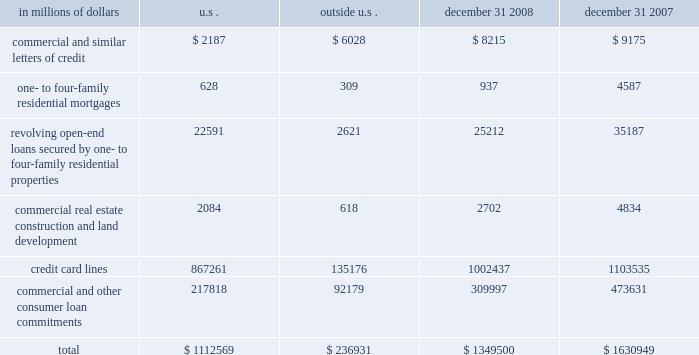Credit commitments the table below summarizes citigroup 2019s other commitments as of december 31 , 2008 and december 31 , 2007 .
In millions of dollars u.s .
Outside december 31 , december 31 .
The majority of unused commitments are contingent upon customers 2019 maintaining specific credit standards .
Commercial commitments generally have floating interest rates and fixed expiration dates and may require payment of fees .
Such fees ( net of certain direct costs ) are deferred and , upon exercise of the commitment , amortized over the life of the loan or , if exercise is deemed remote , amortized over the commitment period .
Commercial and similar letters of credit a commercial letter of credit is an instrument by which citigroup substitutes its credit for that of a customer to enable the customer to finance the purchase of goods or to incur other commitments .
Citigroup issues a letter on behalf of its client to a supplier and agrees to pay the supplier upon presentation of documentary evidence that the supplier has performed in accordance with the terms of the letter of credit .
When drawn , the customer then is required to reimburse citigroup .
One- to four-family residential mortgages a one- to four-family residential mortgage commitment is a written confirmation from citigroup to a seller of a property that the bank will advance the specified sums enabling the buyer to complete the purchase .
Revolving open-end loans secured by one- to four-family residential properties revolving open-end loans secured by one- to four-family residential properties are essentially home equity lines of credit .
A home equity line of credit is a loan secured by a primary residence or second home to the extent of the excess of fair market value over the debt outstanding for the first mortgage .
Commercial real estate , construction and land development commercial real estate , construction and land development include unused portions of commitments to extend credit for the purpose of financing commercial and multifamily residential properties as well as land development projects .
Both secured-by-real-estate and unsecured commitments are included in this line .
In addition , undistributed loan proceeds , where there is an obligation to advance for construction progress , payments are also included in this line .
However , this line only includes those extensions of credit that once funded will be classified as loans on the consolidated balance sheet .
Credit card lines citigroup provides credit to customers by issuing credit cards .
The credit card lines are unconditionally cancellable by the issuer .
Commercial and other consumer loan commitments commercial and other consumer loan commitments include commercial commitments to make or purchase loans , to purchase third-party receivables and to provide note issuance or revolving underwriting facilities .
Amounts include $ 140 billion and $ 259 billion with an original maturity of less than one year at december 31 , 2008 and december 31 , 2007 , respectively .
In addition , included in this line item are highly leveraged financing commitments which are agreements that provide funding to a borrower with higher levels of debt ( measured by the ratio of debt capital to equity capital of the borrower ) than is generally considered normal for other companies .
This type of financing is commonly employed in corporate acquisitions , management buy-outs and similar transactions. .
What percentage of citigroup 2019s total other commitments as of december 31 , 2008 are comprised of credit card lines? 
Computations: (1002437 / 1349500)
Answer: 0.74282. 